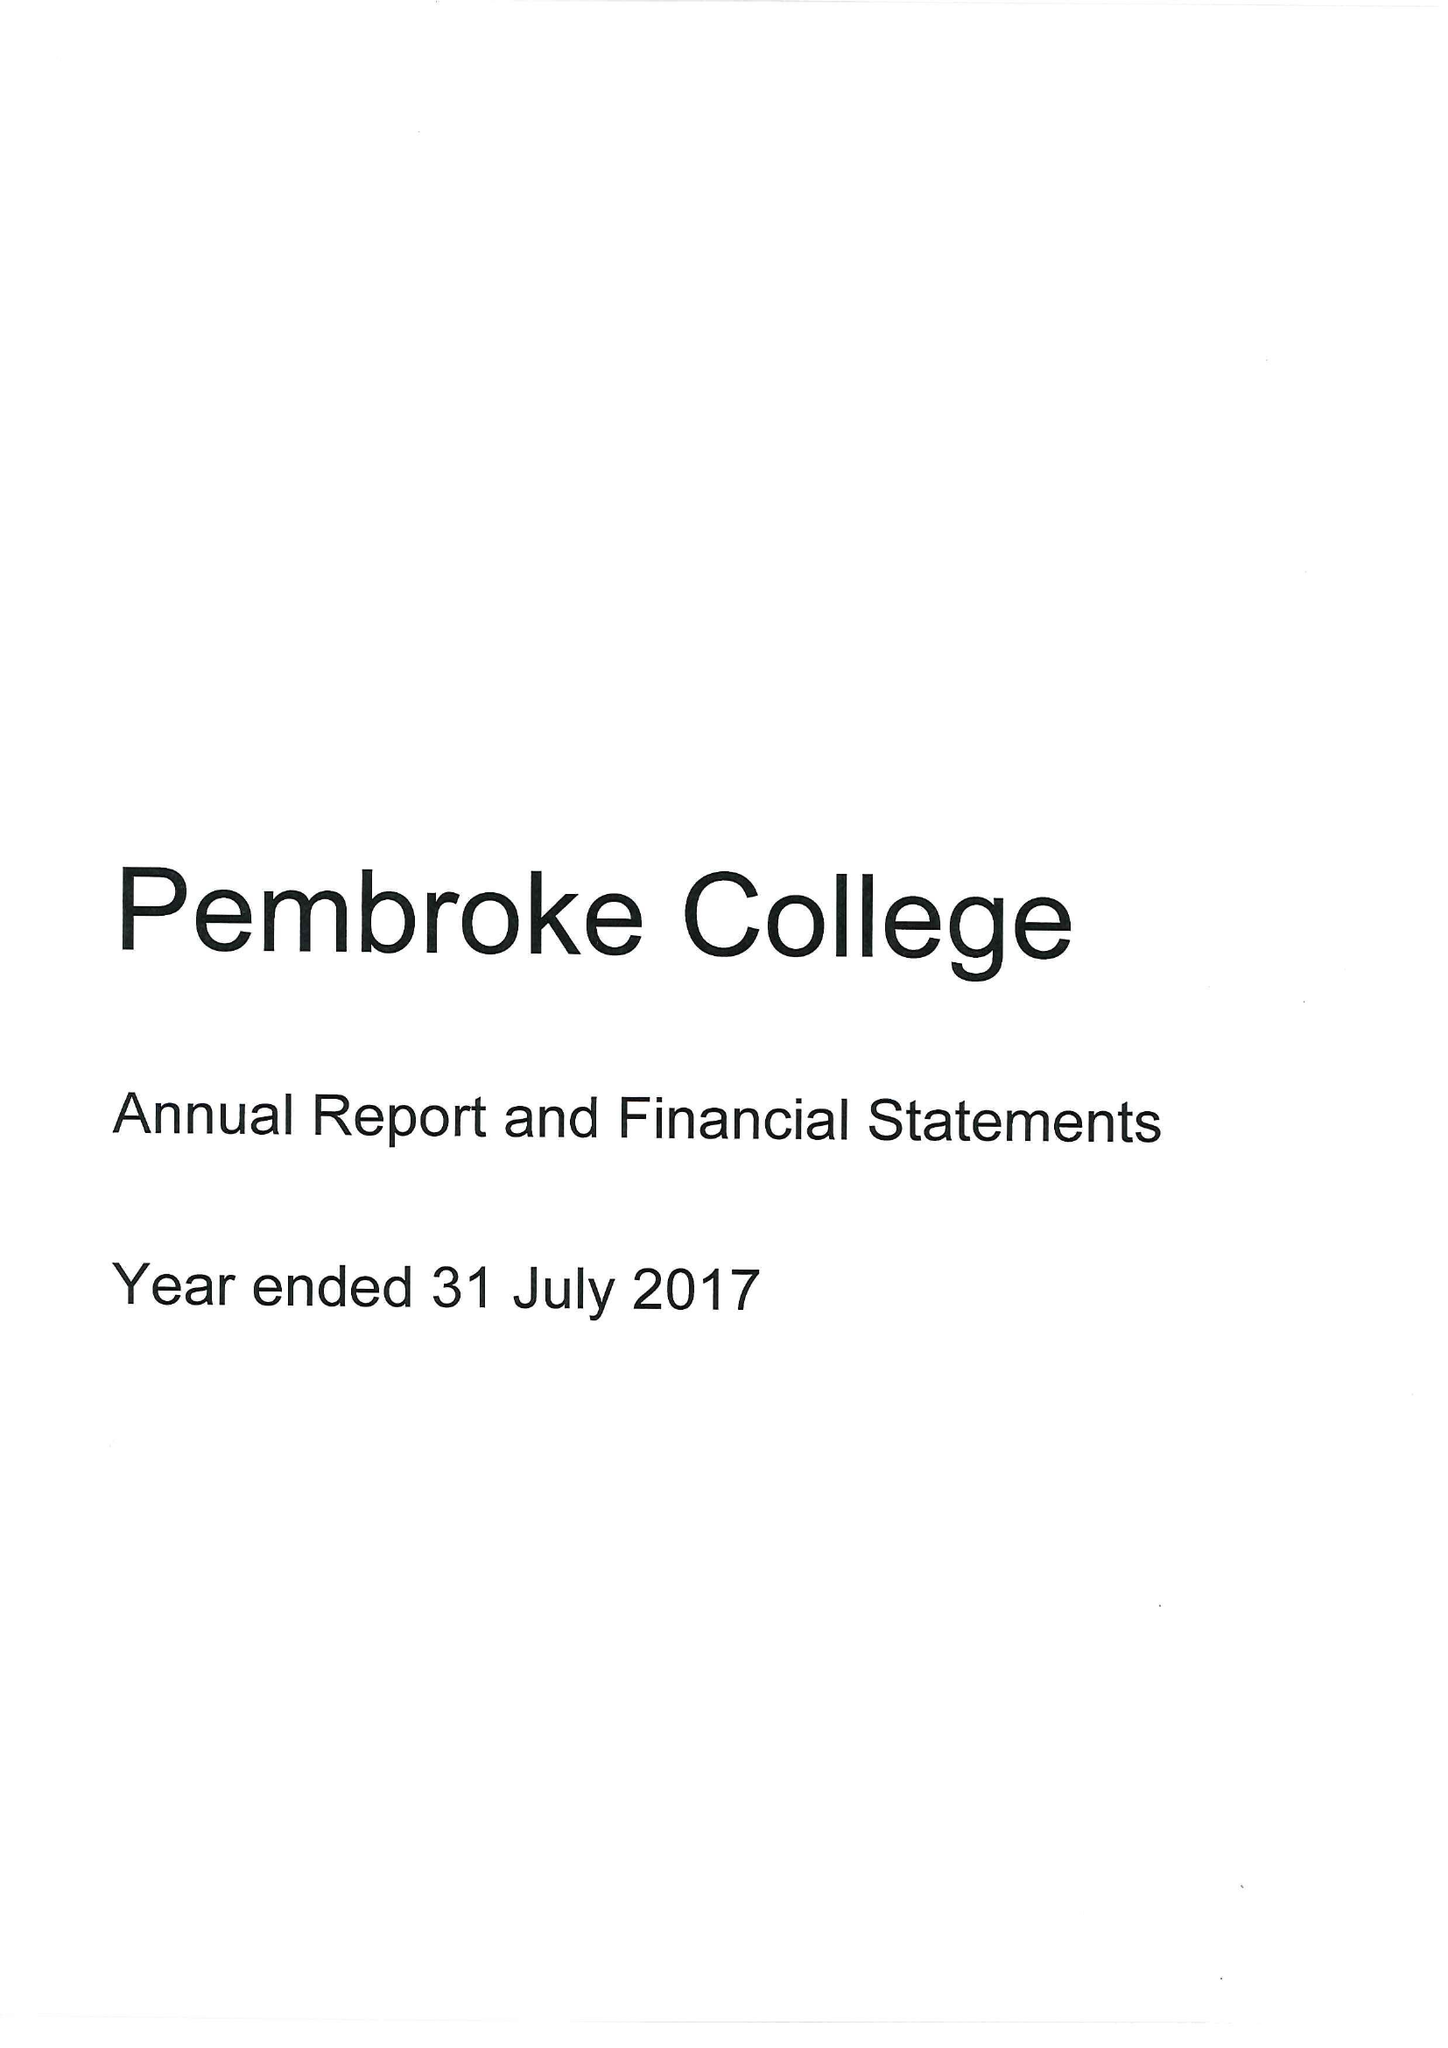What is the value for the charity_number?
Answer the question using a single word or phrase. 1137498 